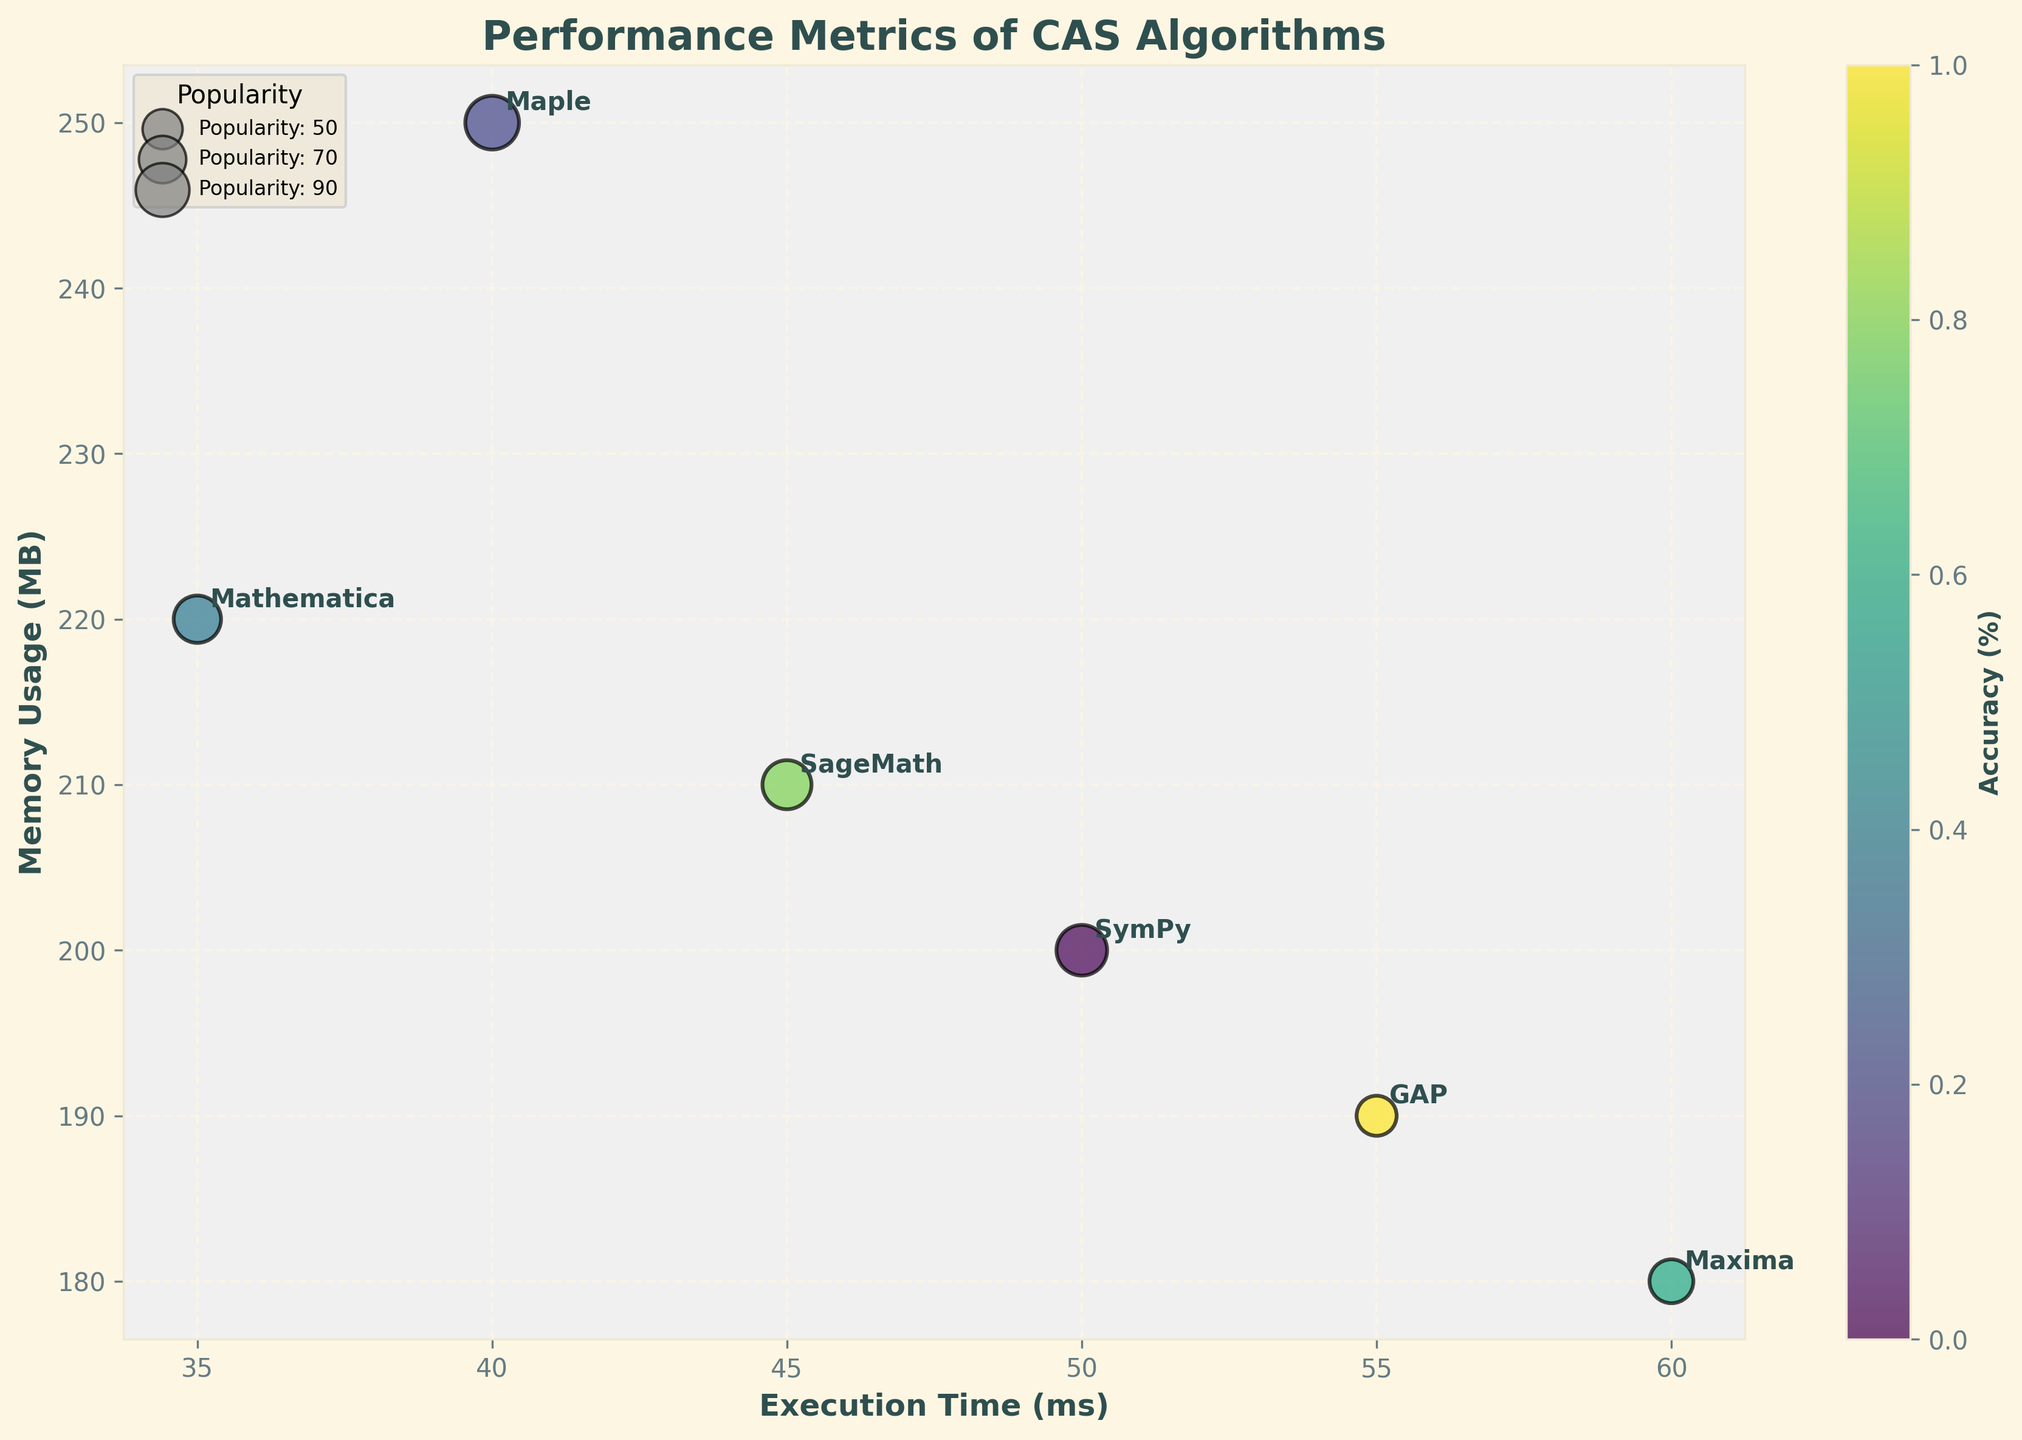What's the title of the figure? The title of the figure is displayed prominently at the top of the chart.
Answer: Performance Metrics of CAS Algorithms How many algorithms are represented in the chart? Each bubble on the chart represents a unique algorithm, and there are labels for each bubble. Count the unique labels.
Answer: 6 Which algorithm has the highest memory usage? Look for the bubble with the highest value on the y-axis and check the corresponding label.
Answer: Maple Which algorithm has the lowest execution time? Identify the bubble closest to the origin on the x-axis and check the corresponding label.
Answer: Mathematica Which algorithm is represented by the largest bubble? The size of the bubble indicates popularity, so the largest bubble corresponds to the highest popularity value. Check for the largest circle.
Answer: Maple Which algorithm provides the highest accuracy? The bubble color intensity represents accuracy, and the color bar helps identify the highest value.
Answer: Maple Compare the memory usage between SymPy and SageMath. Which one uses more memory? Locate both SymPy and SageMath bubbles on the y-axis and compare their heights.
Answer: SageMath Which algorithm has the worst performance in terms of execution time and memory usage combined? Look for the bubble that is farthest from the origin in both x and y directions.
Answer: Maxima What is the average accuracy of the algorithms represented in the chart? Add the accuracy percentages of all algorithms (95+97+96+92+94+93) and divide by the number of algorithms (6). Calculation: (95+97+96+92+94+93)/6 = 94.5
Answer: 94.5% If you want an algorithm with low execution time but can compromise a bit on memory usage, which one would you choose? Look for an algorithm with the lowest x-value but not the highest y-value. Mathematica has the lowest execution time with acceptable memory usage.
Answer: Mathematica 